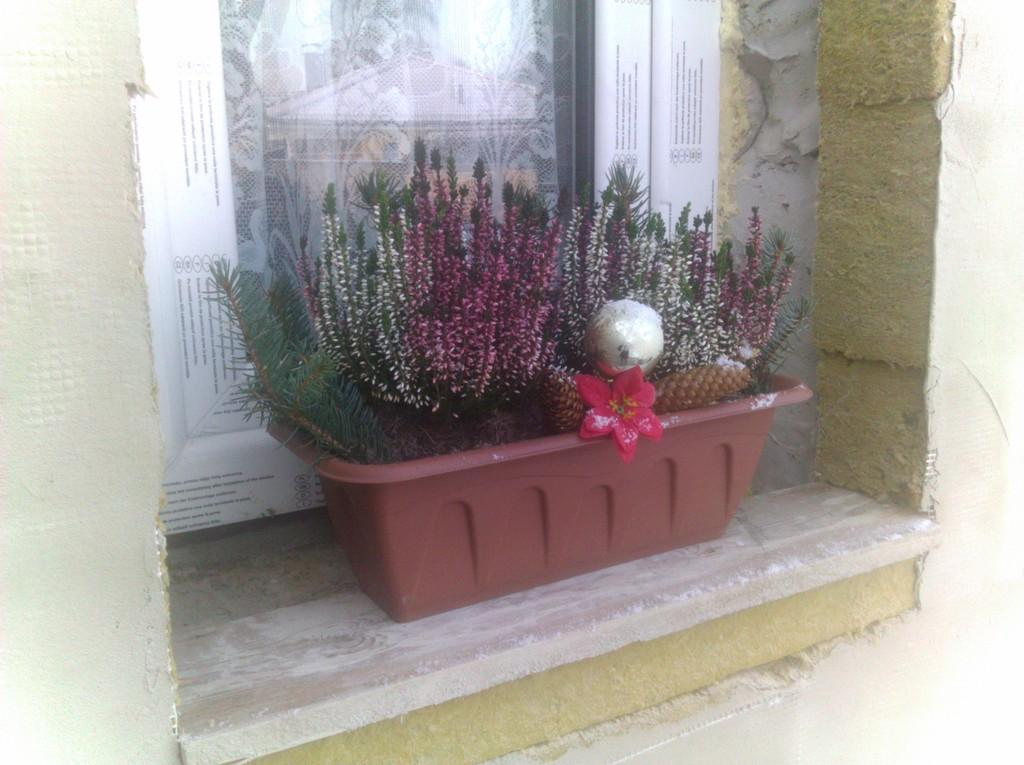What type of living organisms can be seen in the image? Plants can be seen in the image. Can you describe a specific flower in the image? There is a red color flower in the image. What is the flower placed in? The flower is in a brown color pot. How many pigs are wearing collars in the image? There are no pigs or collars present in the image. 